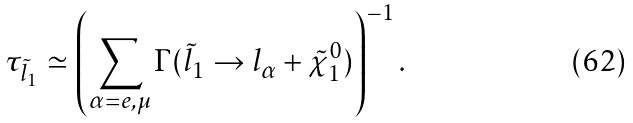<formula> <loc_0><loc_0><loc_500><loc_500>\tau _ { \tilde { l } _ { 1 } } \simeq \left ( \sum _ { \alpha = e , \mu } \Gamma ( \tilde { l } _ { 1 } \to l _ { \alpha } + \tilde { \chi } ^ { 0 } _ { 1 } ) \right ) ^ { - 1 } .</formula> 